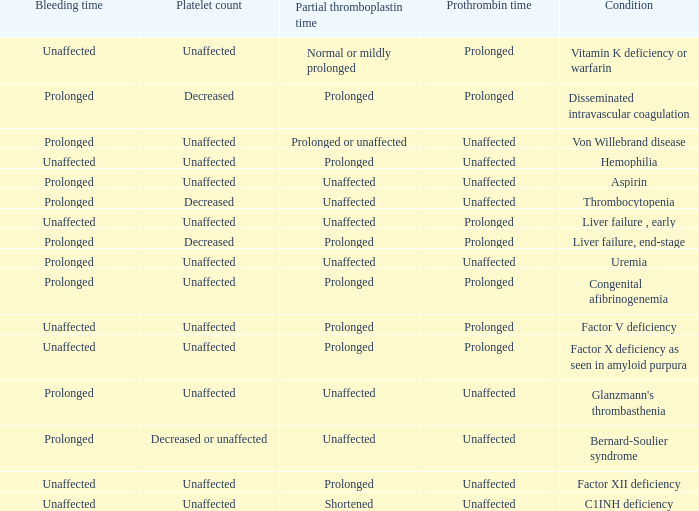Which Bleeding time has a Condition of factor x deficiency as seen in amyloid purpura? Unaffected. 